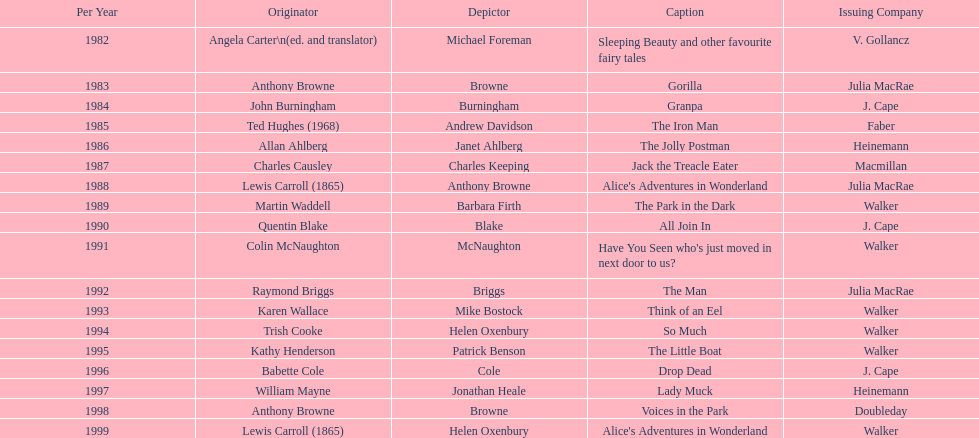What is the only title listed for 1999? Alice's Adventures in Wonderland. 